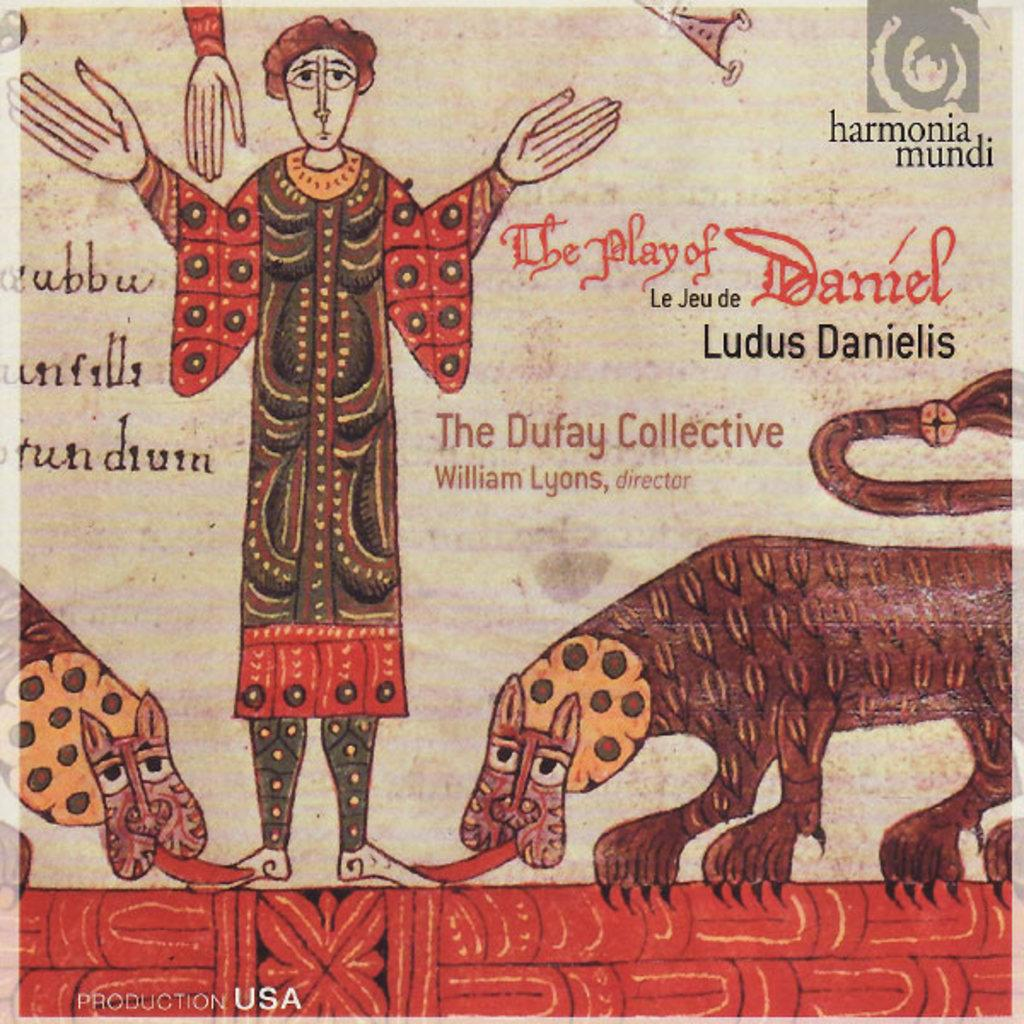What is the main object in the image? There is a poster in the image. What can be seen on the poster? The poster contains depictions of a person and two animals. Is there any text on the poster? Yes, there is text on the poster. Where is the logo located on the poster? The logo is at the top right corner of the poster. What advice is given in the aftermath of the addition of the third animal to the poster? There is no mention of a third animal or any advice in the image. The poster contains depictions of a person and two animals, with no indication of any additional animals or advice. 